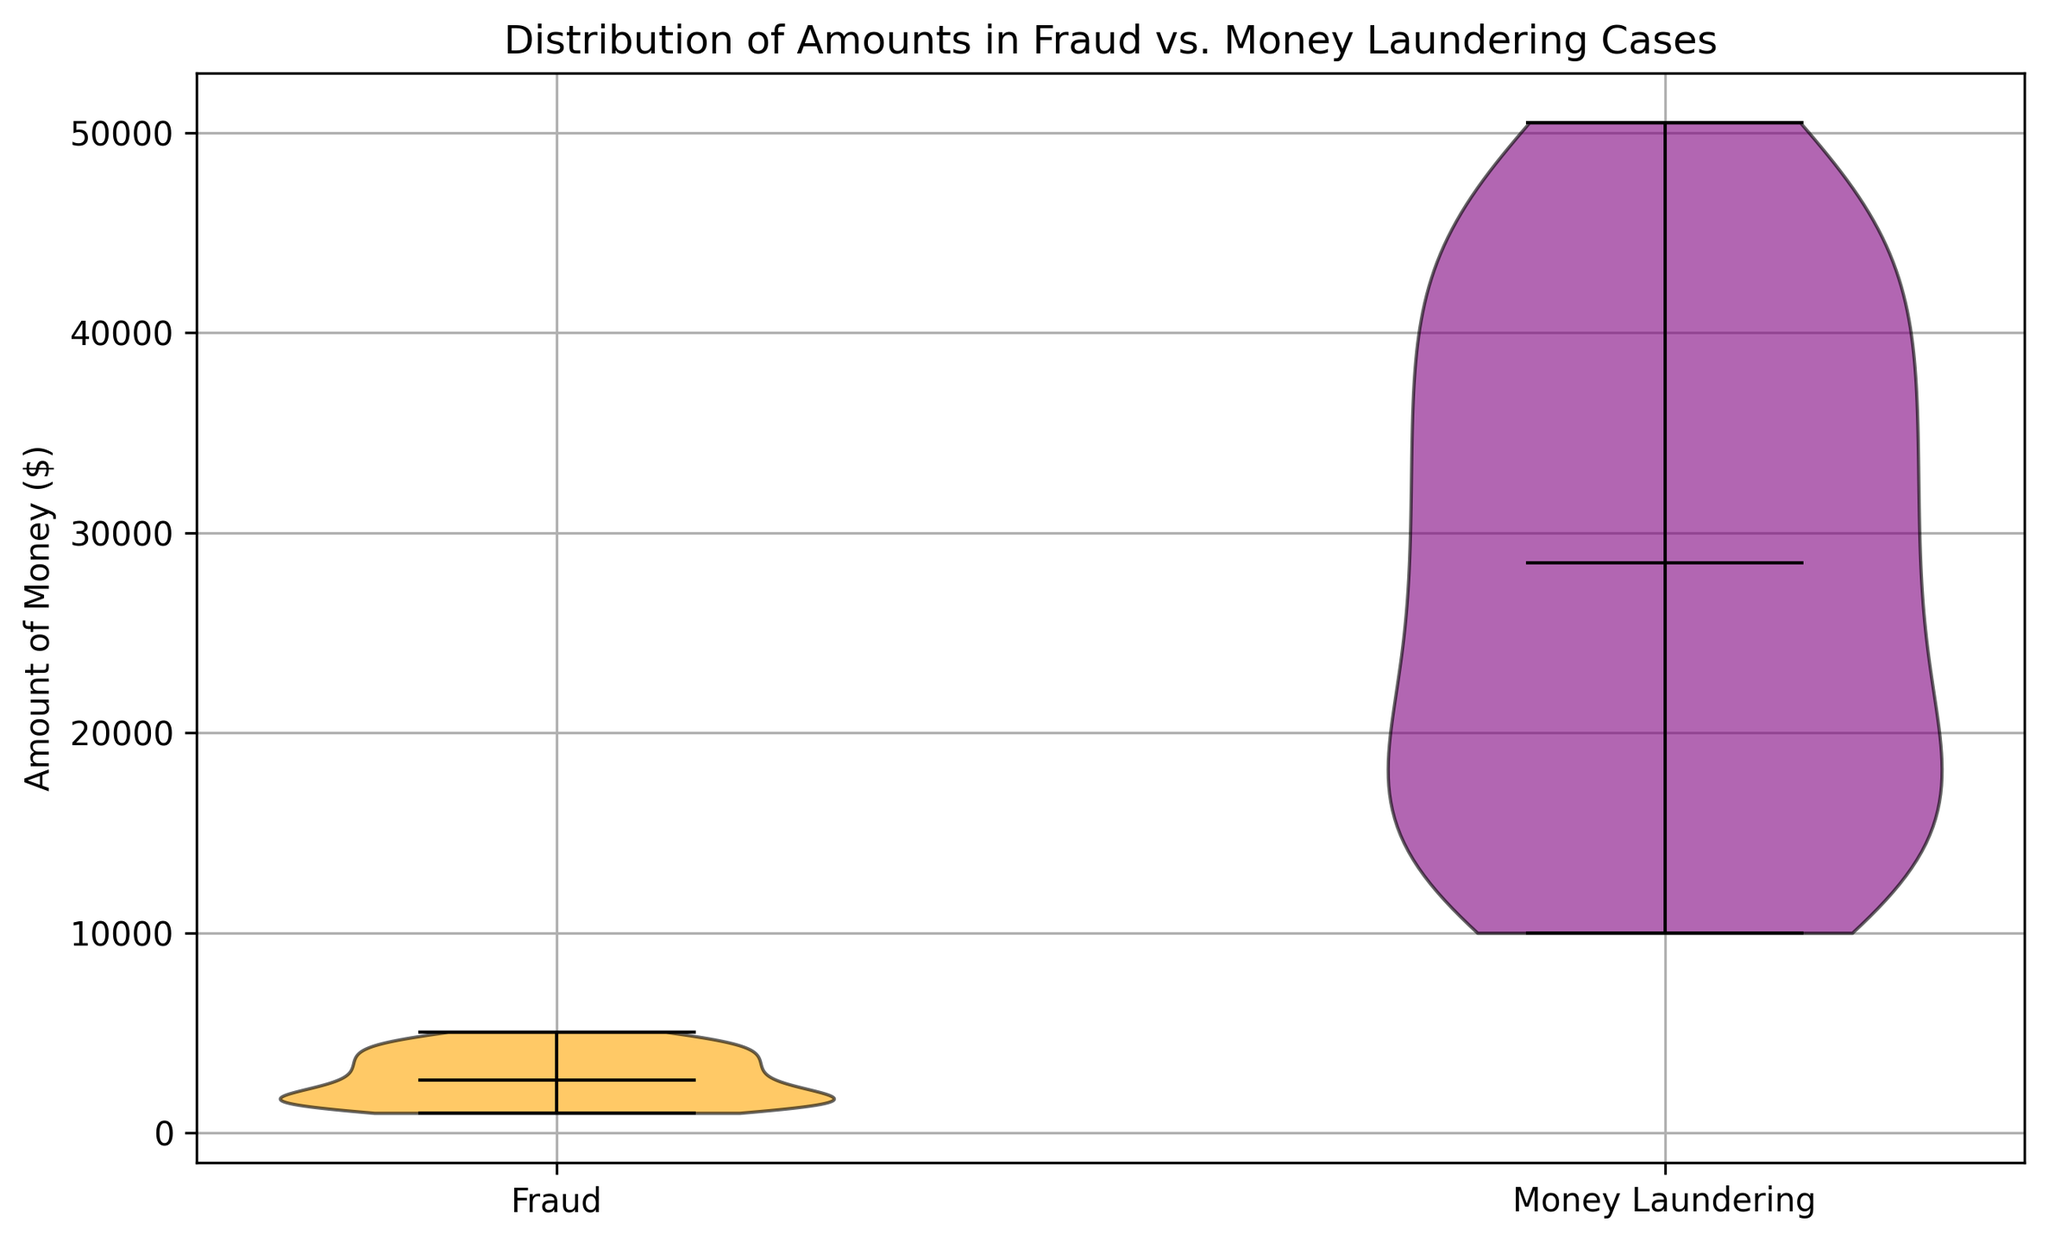which case type shows a higher median amount of money? By examining the violin plot, observe the dark horizontal line within each plot, which represents the median value. Notice that the dark line for Money Laundering is higher on the y-axis than for Fraud.
Answer: Money Laundering What is the color used to represent fraud cases? Look at the color fill of the violins on the plot. The violin representing Fraud is filled with an orange color.
Answer: Orange What's the range of amounts for money laundering cases? Observe the extent of the violin plot for Money Laundering along the y-axis. It spans from 10,000 to 50,500 dollars.
Answer: 10,000 to 50,500 dollars Which type of case exhibits a wider dispersion in the amount of money? Assess the spread or width of the violin plots for both Fraud and Money Laundering. The Money Laundering violin is visibly taller, showing a wider range of data when compared to the Fraud violin.
Answer: Money Laundering Are the median amounts for both cases withing the same range? Compare the height of the dark horizontal lines representing the median values within each violin. The median amount for Fraud is significantly lower than that for Money Laundering.
Answer: No How does the maximum amount in fraud cases compare to the minimum amount in money laundering cases? The highest value in the Fraud violin reaches up to around 5050 dollars, while the minimum value in the Money Laundering violin starts at 10,000 dollars. The maximum in Fraud is less than the minimum in Money Laundering.
Answer: Less than What's the shape difference between the two violin plots? The Fraud violin plot appears more condensed and narrower around its median value, while the Money Laundering violin is more elongated and uniform in width, showing a wider range of data.
Answer: Fraud is condensed; Money Laundering is elongated What is the median value of fraud cases? Locate the dark horizontal line inside the Fraud violin plot and align it with the y-axis. The median value for Fraud cases is about 3,000 dollars.
Answer: 3,000 dollars How does the overall distribution shape differ between fraud and money laundering cases? The Fraud distribution is more narrow and concentrated around its median, indicating less variability. In contrast, Money Laundering is more uniformly distributed over a wider range, indicating more variability in the amounts.
Answer: Fraud is narrow; Money laundering is uniform What’s the interquartile range (IQR) indication from the violin plot shape for fraud cases? The height and shape of the violin plot indicate the IQR. For Fraud, the middle 50% of the data (IQR) seems to be less spread out, suggesting a lower variance compared to Money Laundering.
Answer: Lower variance 